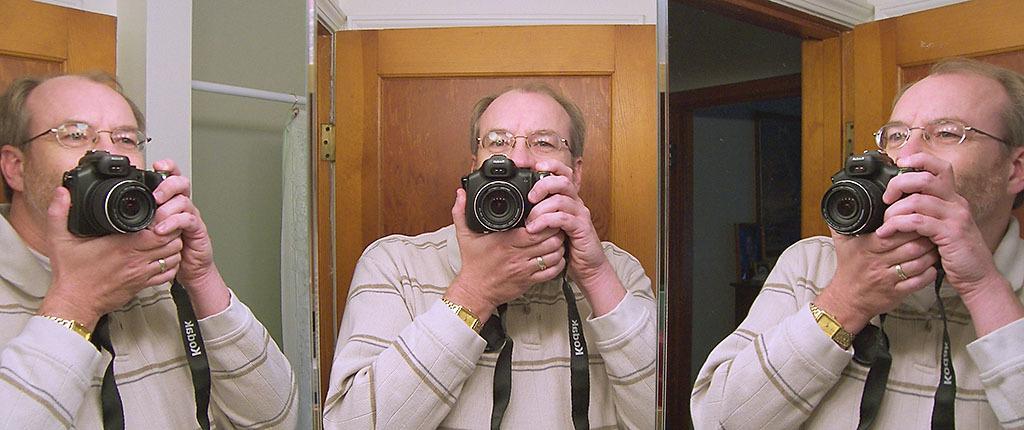How would you summarize this image in a sentence or two? In this picture there are three persons standing and holding the camera in both hands. 